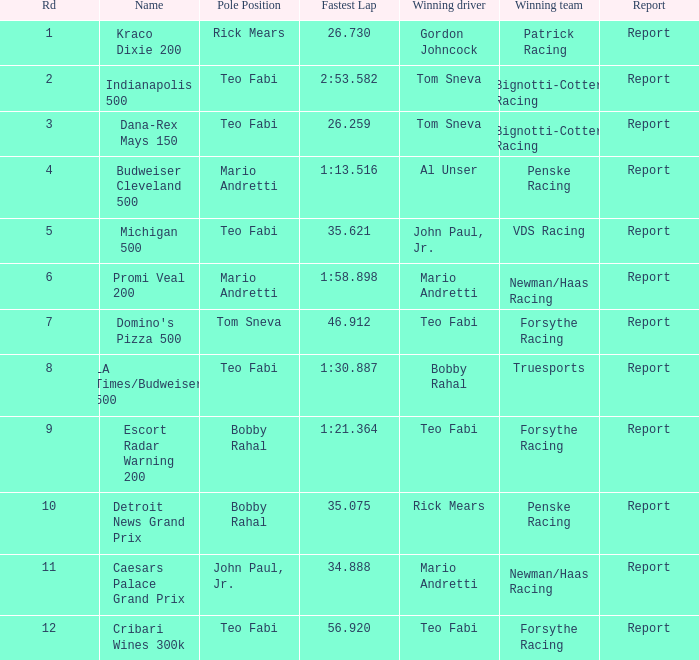What was the fastest lap time in the Escort Radar Warning 200? 1:21.364. 